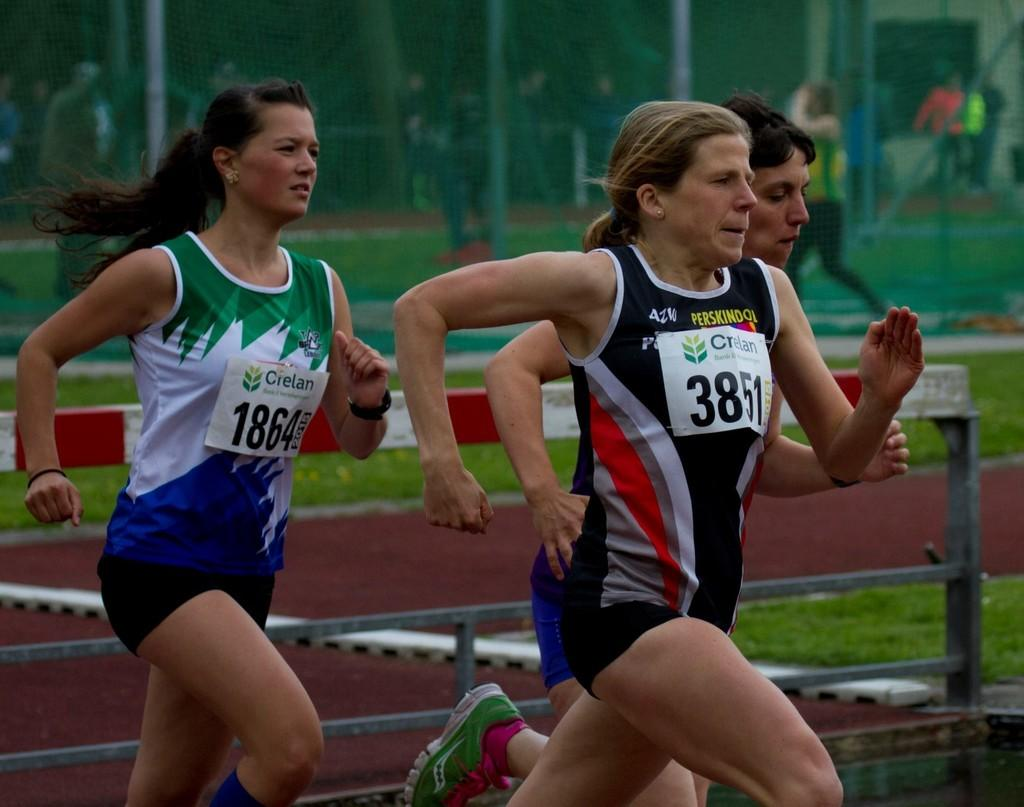Provide a one-sentence caption for the provided image. A group of female runners with the one in the lead wearing number 3851. 